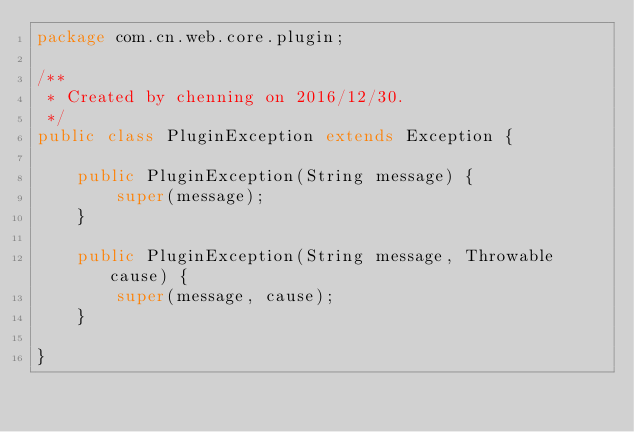<code> <loc_0><loc_0><loc_500><loc_500><_Java_>package com.cn.web.core.plugin;

/**
 * Created by chenning on 2016/12/30.
 */
public class PluginException extends Exception {

    public PluginException(String message) {
        super(message);
    }

    public PluginException(String message, Throwable cause) {
        super(message, cause);
    }

}
</code> 